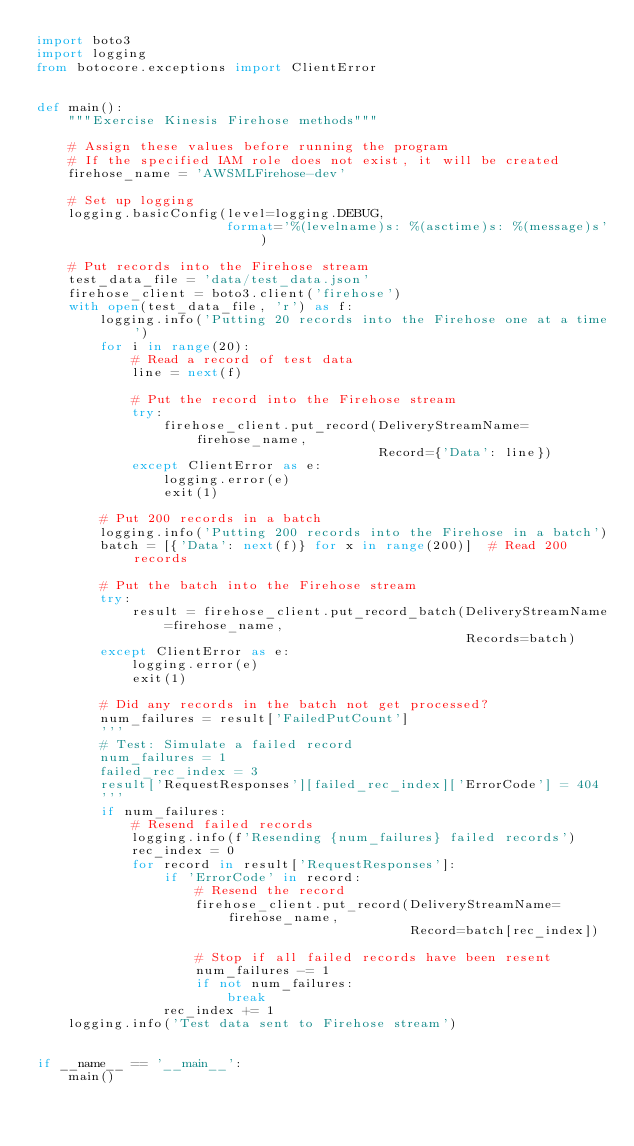Convert code to text. <code><loc_0><loc_0><loc_500><loc_500><_Python_>import boto3
import logging
from botocore.exceptions import ClientError


def main():
    """Exercise Kinesis Firehose methods"""

    # Assign these values before running the program
    # If the specified IAM role does not exist, it will be created
    firehose_name = 'AWSMLFirehose-dev'

    # Set up logging
    logging.basicConfig(level=logging.DEBUG,
                        format='%(levelname)s: %(asctime)s: %(message)s')

    # Put records into the Firehose stream
    test_data_file = 'data/test_data.json'
    firehose_client = boto3.client('firehose')
    with open(test_data_file, 'r') as f:
        logging.info('Putting 20 records into the Firehose one at a time')
        for i in range(20):
            # Read a record of test data
            line = next(f)

            # Put the record into the Firehose stream
            try:
                firehose_client.put_record(DeliveryStreamName=firehose_name,
                                           Record={'Data': line})
            except ClientError as e:
                logging.error(e)
                exit(1)

        # Put 200 records in a batch
        logging.info('Putting 200 records into the Firehose in a batch')
        batch = [{'Data': next(f)} for x in range(200)]  # Read 200 records

        # Put the batch into the Firehose stream
        try:
            result = firehose_client.put_record_batch(DeliveryStreamName=firehose_name,
                                                      Records=batch)
        except ClientError as e:
            logging.error(e)
            exit(1)

        # Did any records in the batch not get processed?
        num_failures = result['FailedPutCount']
        '''
        # Test: Simulate a failed record
        num_failures = 1
        failed_rec_index = 3
        result['RequestResponses'][failed_rec_index]['ErrorCode'] = 404
        '''
        if num_failures:
            # Resend failed records
            logging.info(f'Resending {num_failures} failed records')
            rec_index = 0
            for record in result['RequestResponses']:
                if 'ErrorCode' in record:
                    # Resend the record
                    firehose_client.put_record(DeliveryStreamName=firehose_name,
                                               Record=batch[rec_index])

                    # Stop if all failed records have been resent
                    num_failures -= 1
                    if not num_failures:
                        break
                rec_index += 1
    logging.info('Test data sent to Firehose stream')


if __name__ == '__main__':
    main()
</code> 